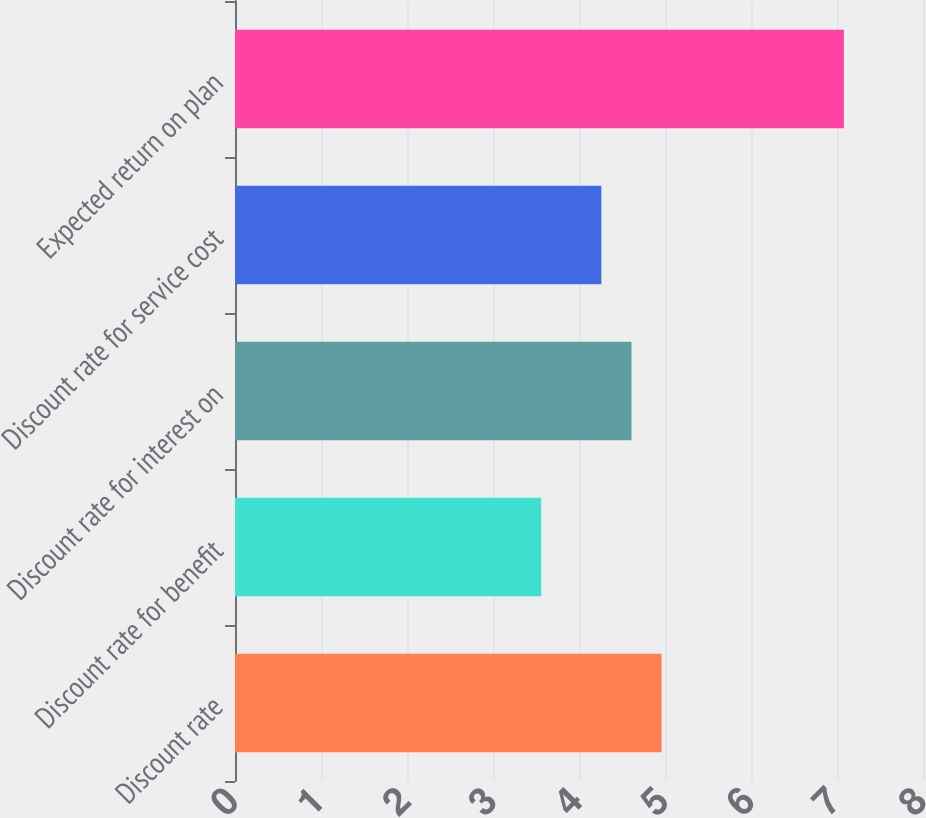Convert chart to OTSL. <chart><loc_0><loc_0><loc_500><loc_500><bar_chart><fcel>Discount rate<fcel>Discount rate for benefit<fcel>Discount rate for interest on<fcel>Discount rate for service cost<fcel>Expected return on plan<nl><fcel>4.96<fcel>3.56<fcel>4.61<fcel>4.26<fcel>7.08<nl></chart> 